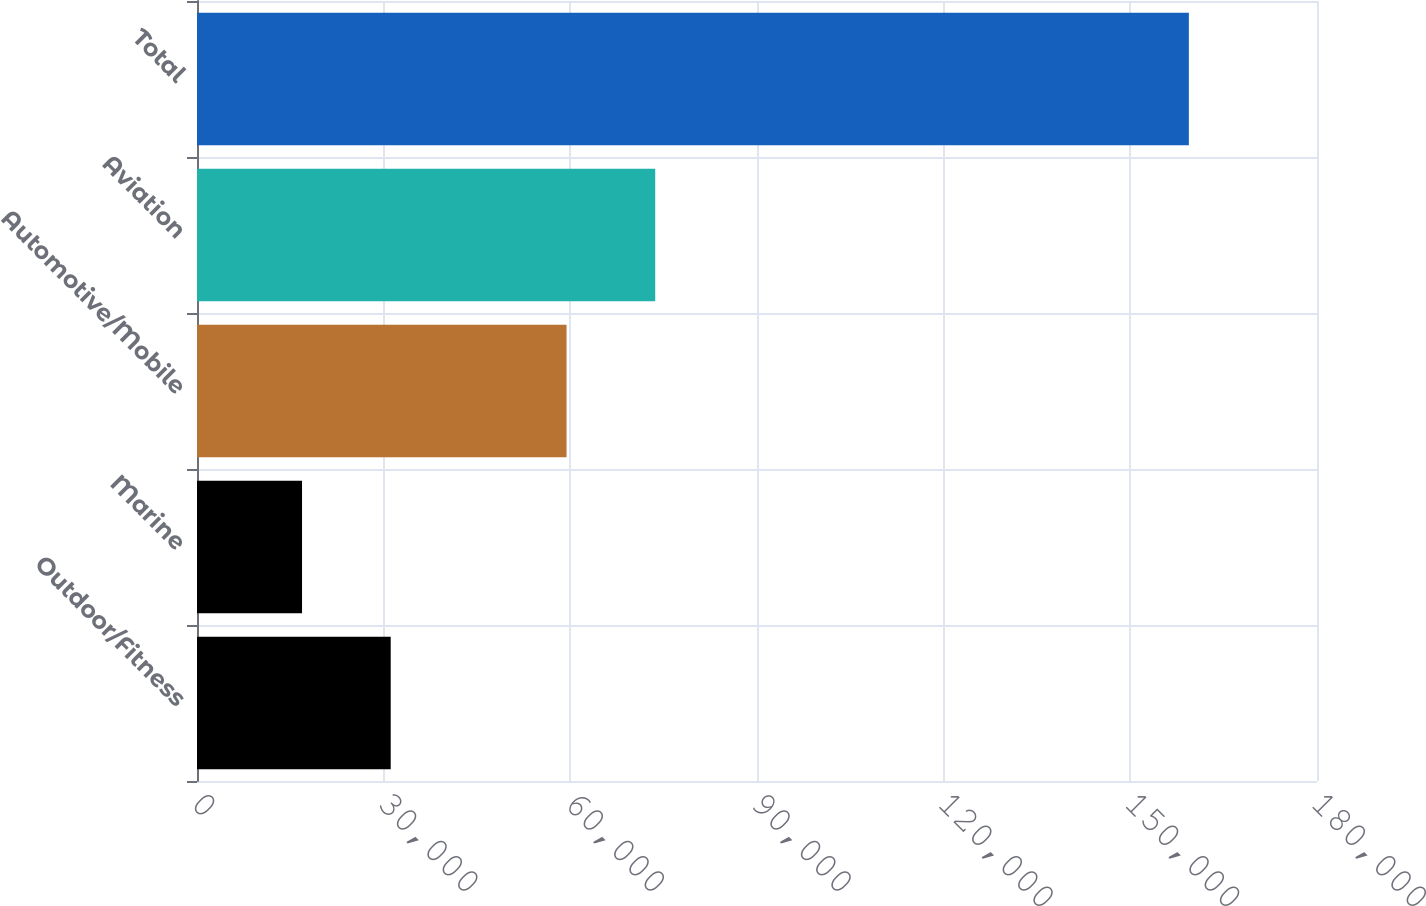Convert chart to OTSL. <chart><loc_0><loc_0><loc_500><loc_500><bar_chart><fcel>Outdoor/Fitness<fcel>Marine<fcel>Automotive/Mobile<fcel>Aviation<fcel>Total<nl><fcel>31131.7<fcel>16879<fcel>59390<fcel>73642.7<fcel>159406<nl></chart> 